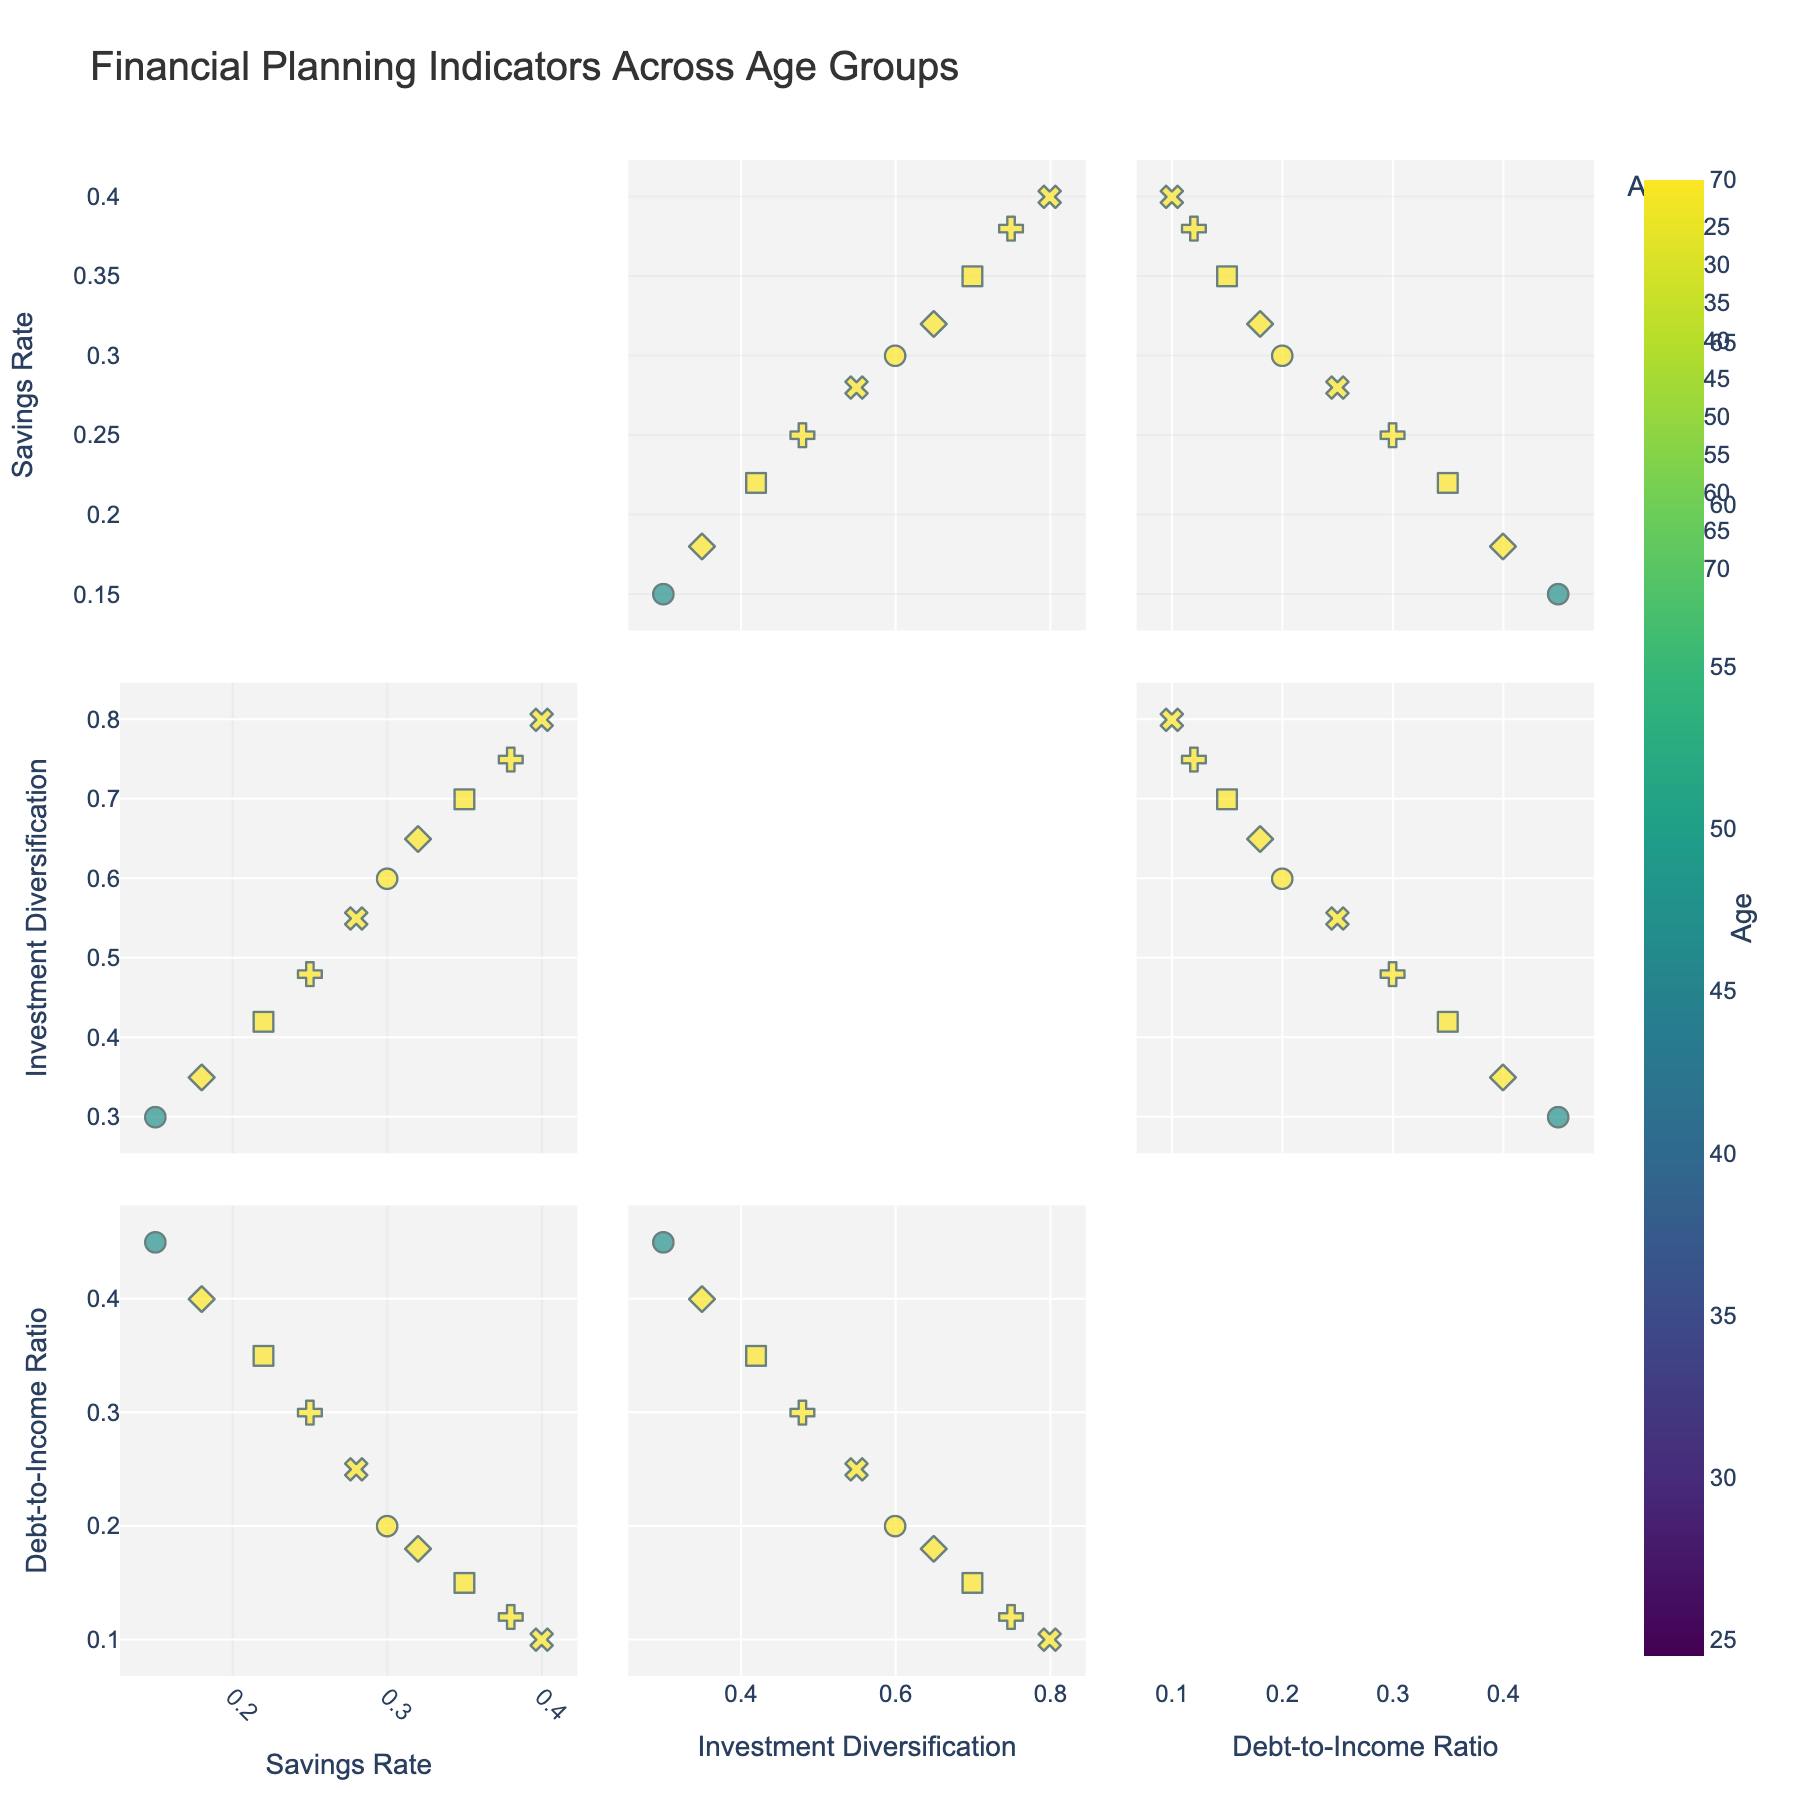What's the title of the scatterplot matrix? The title can be found at the top of the figure. It describes the overall content of the scatterplot matrix.
Answer: Financial Planning Indicators Across Age Groups What color scale is used to represent age in the scatterplot matrix? The color scale is indicated in the colorbar on the right side of the figure, showing a transition from one color to another to denote different ages.
Answer: Viridis How does the Savings Rate trend with increasing age? By observing the scatter points along the Savings Rate dimension, one can see if they generally increase or decrease with advancing age groups.
Answer: It generally increases At which age does Investment Diversification reach the value of approximately 0.60? Check the Investment Diversification axis for the value 0.60 and then correlate it with the age represented in the color scale or labeled symbol.
Answer: Age 50 How does the Debt-to-Income Ratio for individuals aged 60 compare to those aged 30? Identify the symbols or colors representing ages 60 and 30, and look for their respective Debt-to-Income Ratio values to compare them.
Answer: Age 60 is lower Which age group has the highest Savings Rate? Scan the figure for the highest Savings Rate value and then refer to the associated age group either by color or symbol.
Answer: Age 70 Is there a clear relationship between Savings Rate and Debt-to-Income Ratio? Examine the scatter points that plot Savings Rate against Debt-to-Income Ratio to see if there's a discernible pattern or trend.
Answer: Yes, generally inversely related Between the age groups 45 and 55, which has a lower Debt-to-Income Ratio? Directly compare the Debt-to-Income Ratio values for ages 45 and 55 on the plot.
Answer: Age 55 